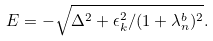<formula> <loc_0><loc_0><loc_500><loc_500>E = - \sqrt { \Delta ^ { 2 } + \epsilon _ { k } ^ { 2 } / ( 1 + \lambda ^ { b } _ { n } ) ^ { 2 } } .</formula> 